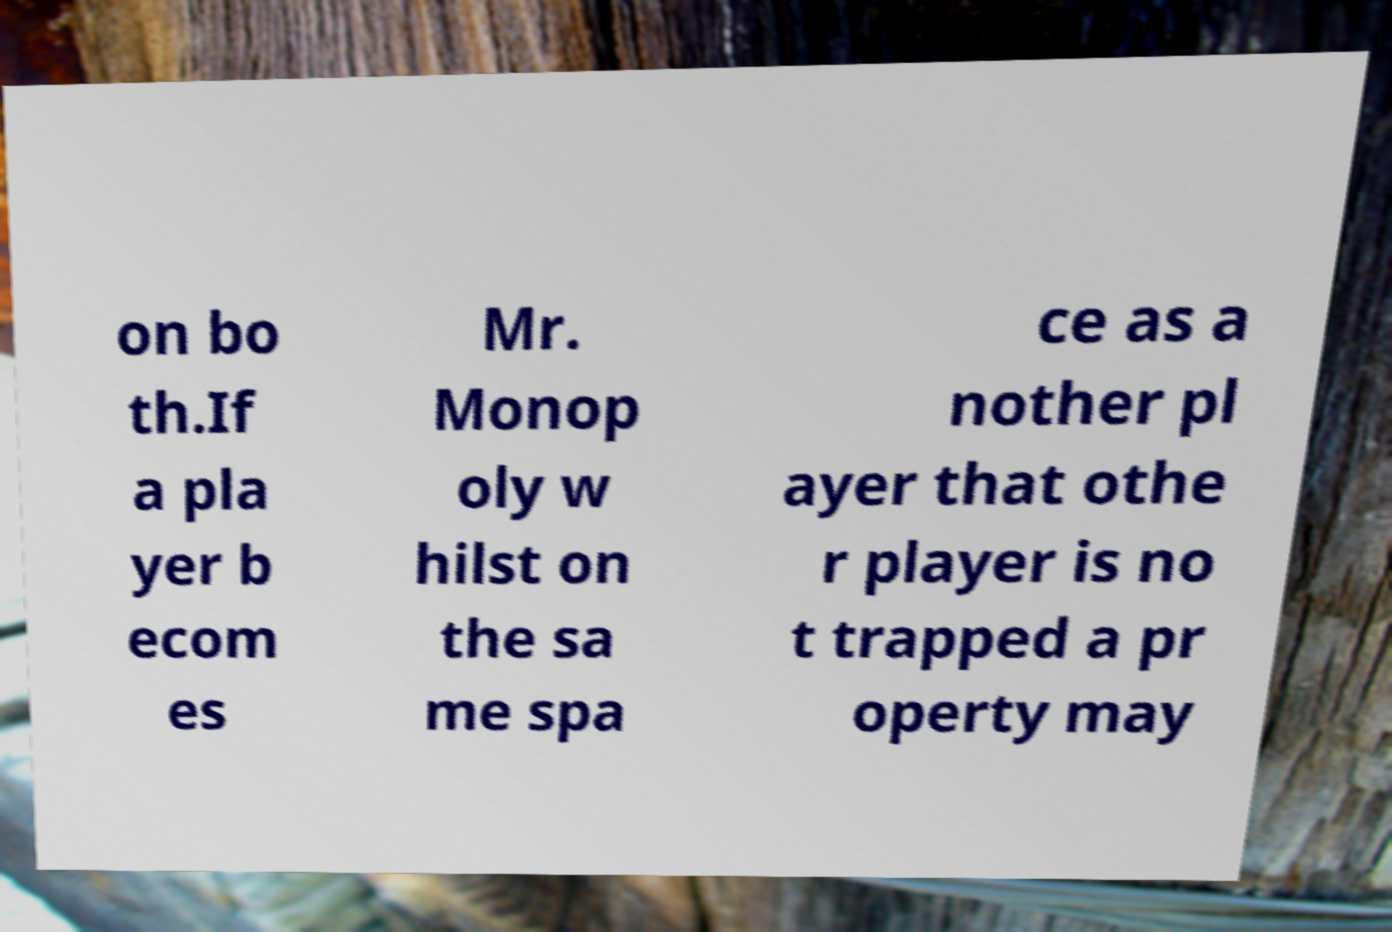Can you read and provide the text displayed in the image?This photo seems to have some interesting text. Can you extract and type it out for me? on bo th.If a pla yer b ecom es Mr. Monop oly w hilst on the sa me spa ce as a nother pl ayer that othe r player is no t trapped a pr operty may 